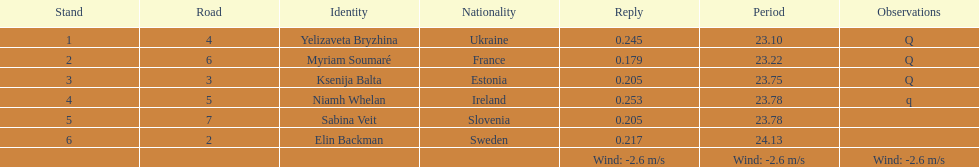Which athlete hails from ireland? Niamh Whelan. 